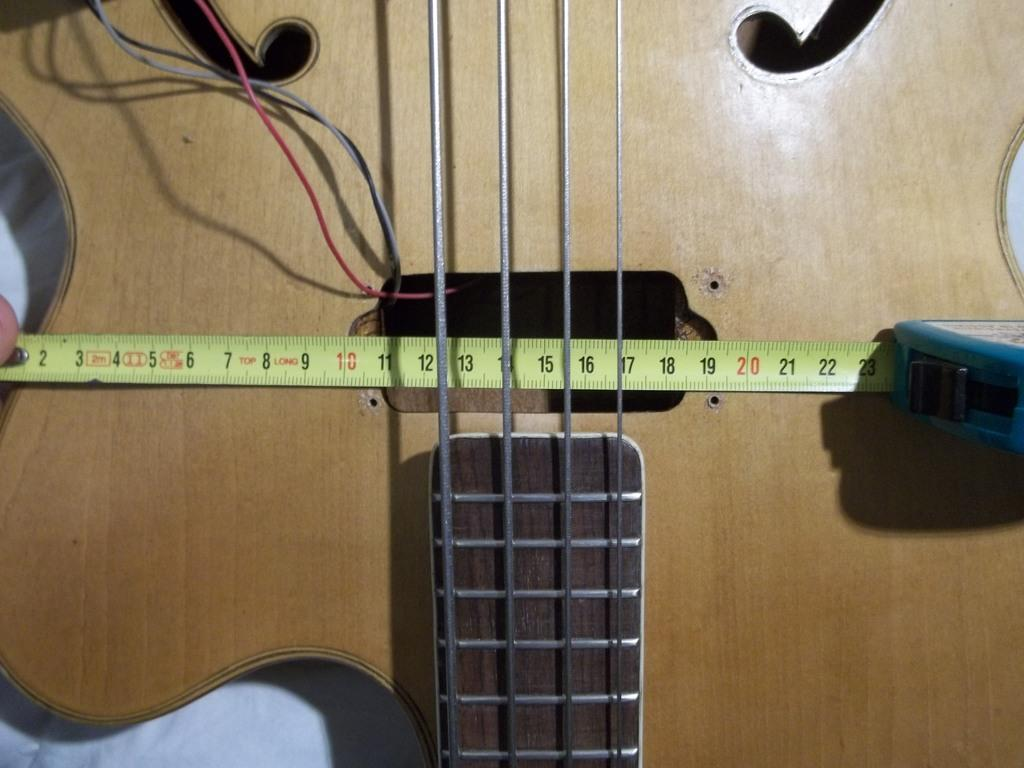What musical instrument is present in the image? There is a guitar in the image. What are the guitar's main components? The guitar has strings. Is there anything attached to the guitar in the image? Yes, there is a tape placed on the guitar. What type of club can be seen in the image? There is no club present in the image; it features a guitar with strings and a tape. What is the taste of the guitar in the image? Guitars do not have a taste, as they are musical instruments and not food items. 